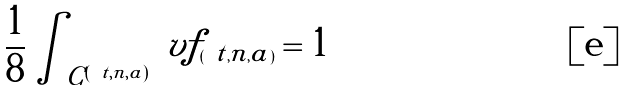Convert formula to latex. <formula><loc_0><loc_0><loc_500><loc_500>\frac { 1 } { 8 } \int _ { C ^ { ( \ t , n , a ) } } \ v f _ { ( \ t , n , a ) } = 1</formula> 